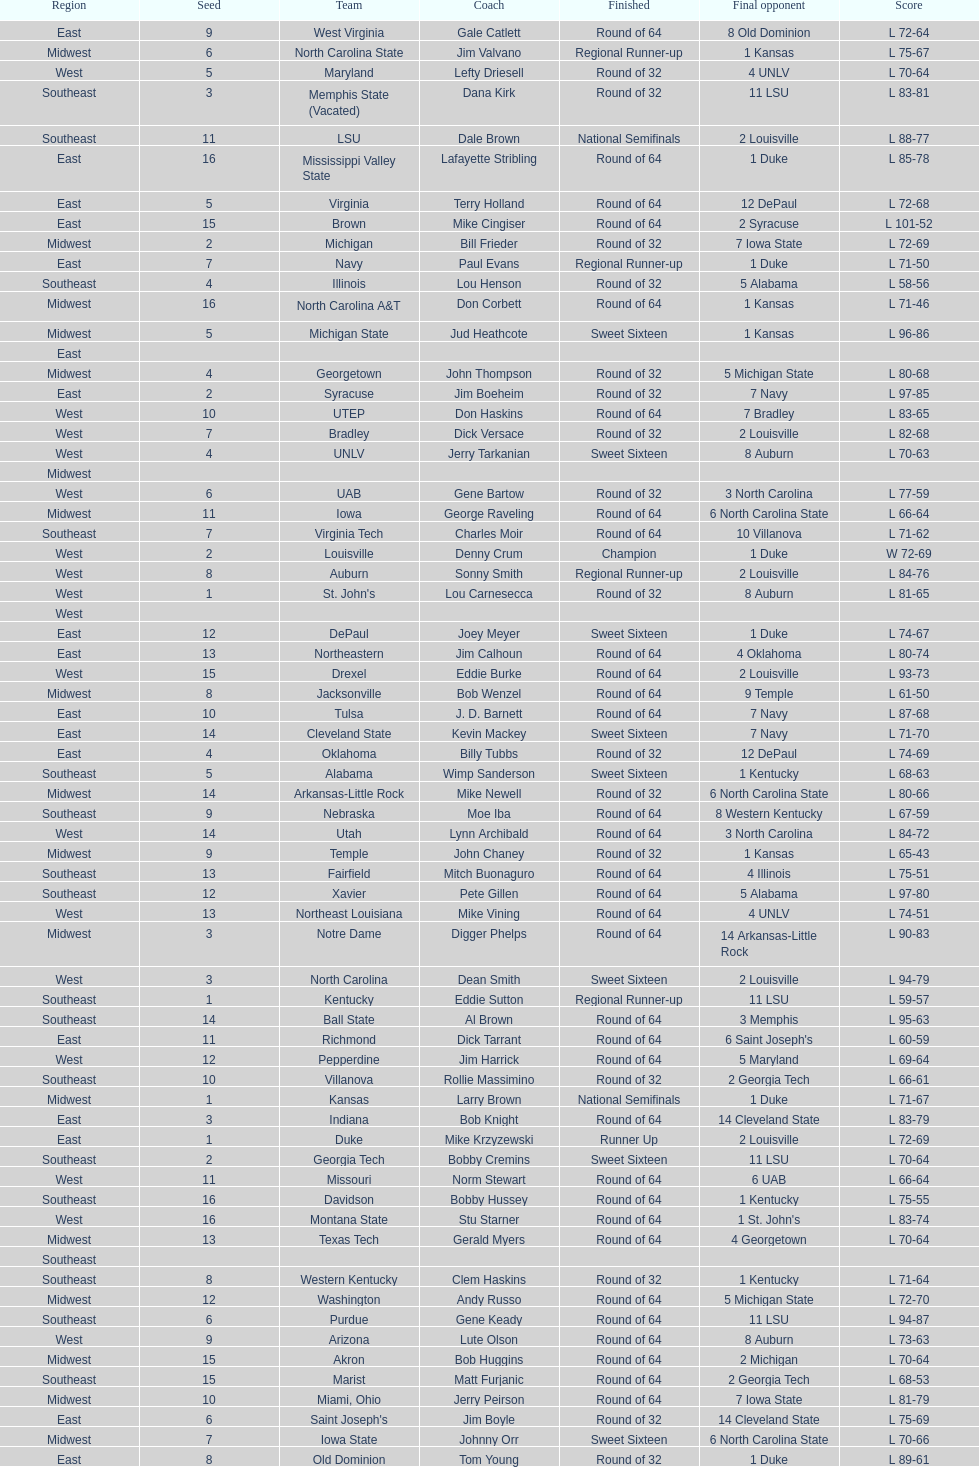What team finished at the top of all else and was finished as champions? Louisville. 